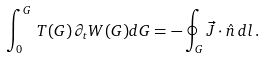<formula> <loc_0><loc_0><loc_500><loc_500>\int _ { 0 } ^ { G } \, T ( G ) \, \partial _ { t } { W } ( G ) d G = - \oint _ { G } \vec { J } \cdot \hat { n } \, d l \, .</formula> 